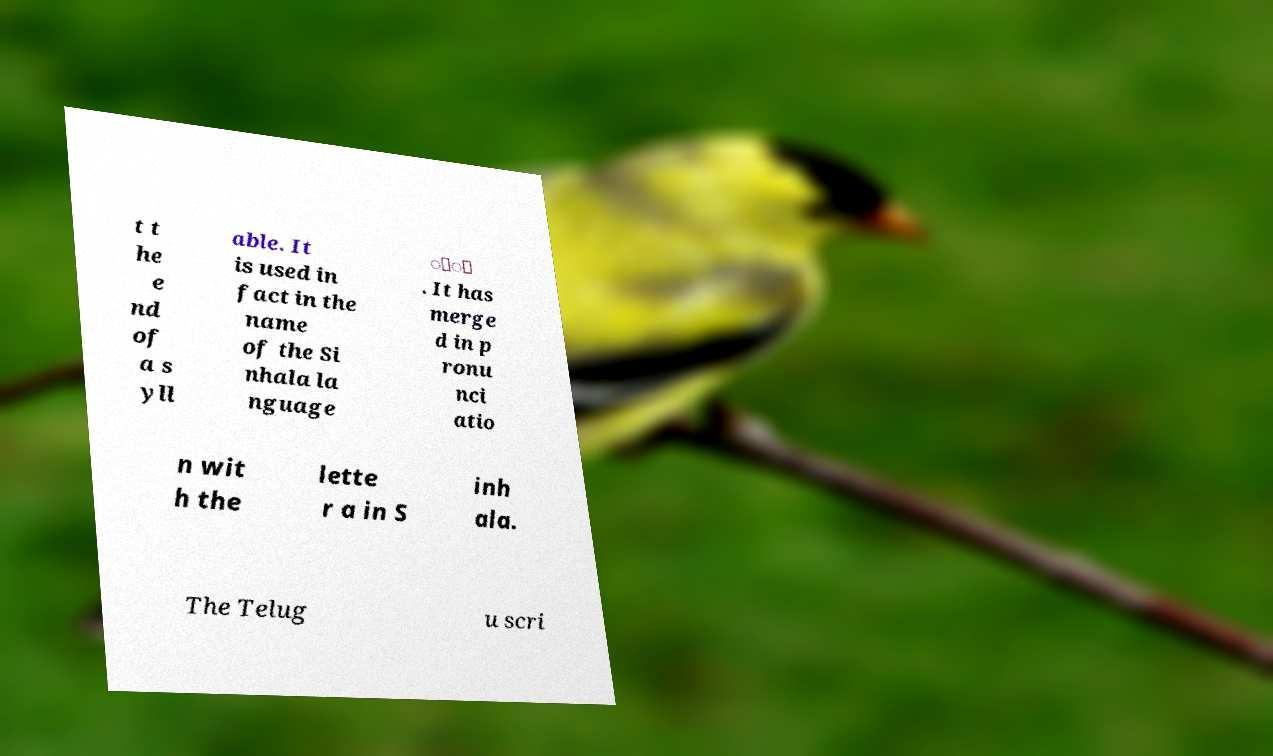Can you read and provide the text displayed in the image?This photo seems to have some interesting text. Can you extract and type it out for me? t t he e nd of a s yll able. It is used in fact in the name of the Si nhala la nguage ිං . It has merge d in p ronu nci atio n wit h the lette r a in S inh ala. The Telug u scri 